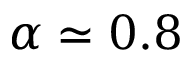<formula> <loc_0><loc_0><loc_500><loc_500>\alpha \simeq 0 . 8</formula> 